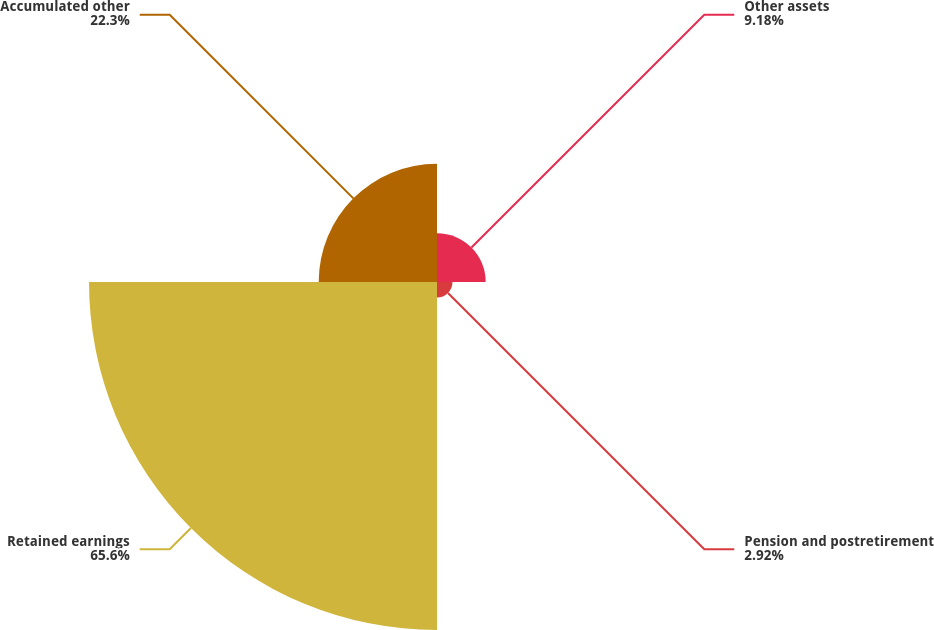Convert chart to OTSL. <chart><loc_0><loc_0><loc_500><loc_500><pie_chart><fcel>Other assets<fcel>Pension and postretirement<fcel>Retained earnings<fcel>Accumulated other<nl><fcel>9.18%<fcel>2.92%<fcel>65.6%<fcel>22.3%<nl></chart> 